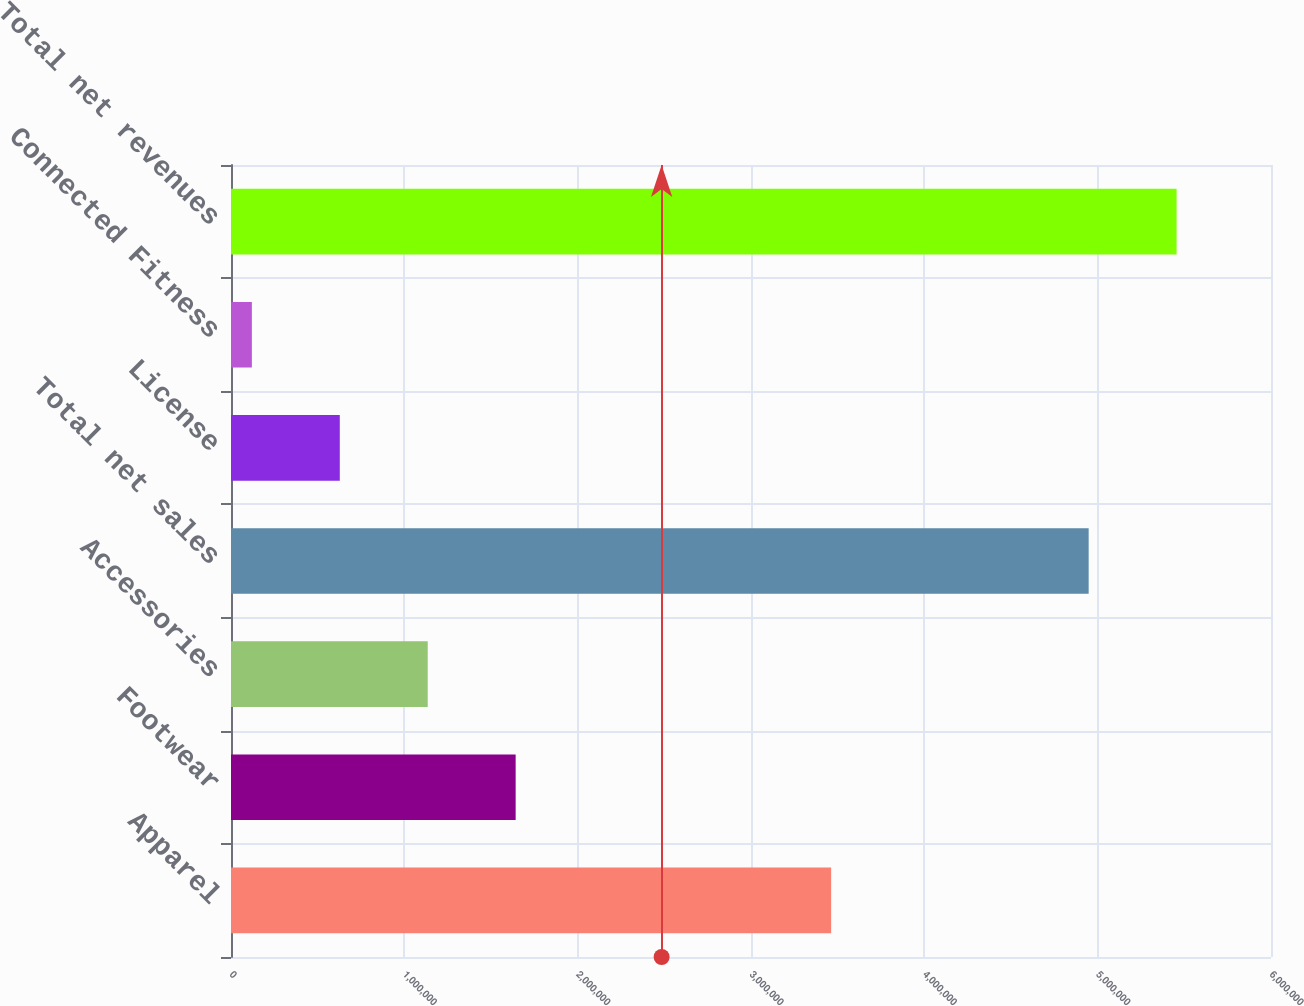Convert chart. <chart><loc_0><loc_0><loc_500><loc_500><bar_chart><fcel>Apparel<fcel>Footwear<fcel>Accessories<fcel>Total net sales<fcel>License<fcel>Connected Fitness<fcel>Total net revenues<nl><fcel>3.46237e+06<fcel>1.64221e+06<fcel>1.13492e+06<fcel>4.94804e+06<fcel>627640<fcel>120357<fcel>5.45533e+06<nl></chart> 